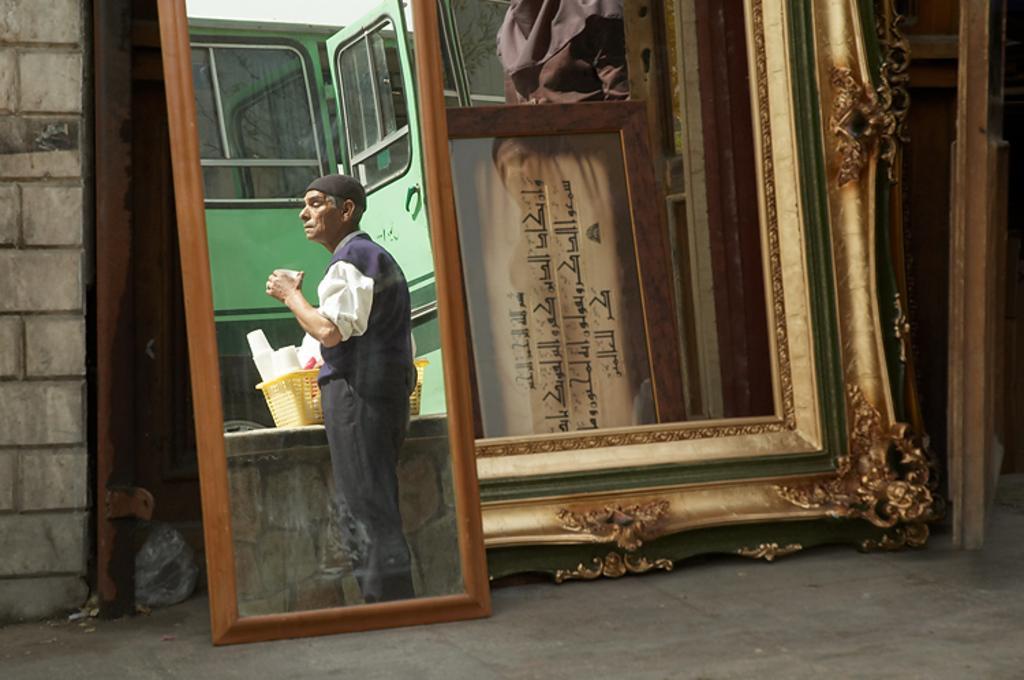Please provide a concise description of this image. This is the mirror. I can see the reflection of the man standing and holding a glass. This looks like a basket with the glasses in it is placed on the wall. I think this is a vehicle. This looks like a frame. On the left side of the image, that looks like a wall. 